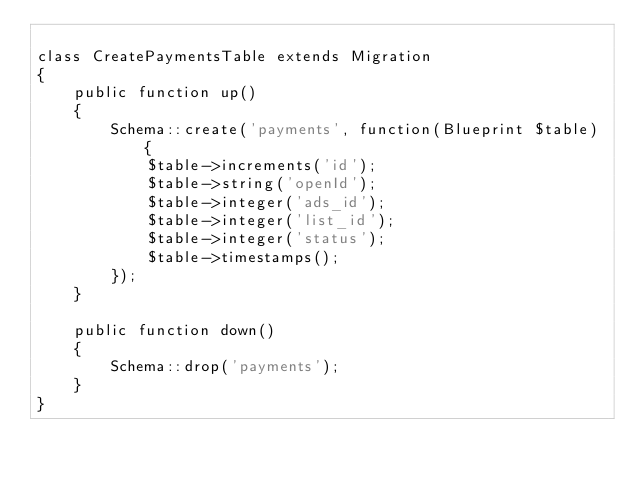<code> <loc_0><loc_0><loc_500><loc_500><_PHP_>
class CreatePaymentsTable extends Migration 
{
	public function up()
	{
		Schema::create('payments', function(Blueprint $table) {
            $table->increments('id');
            $table->string('openId');
            $table->integer('ads_id');
            $table->integer('list_id');
            $table->integer('status');
            $table->timestamps();
        });
	}

	public function down()
	{
		Schema::drop('payments');
	}
}
</code> 